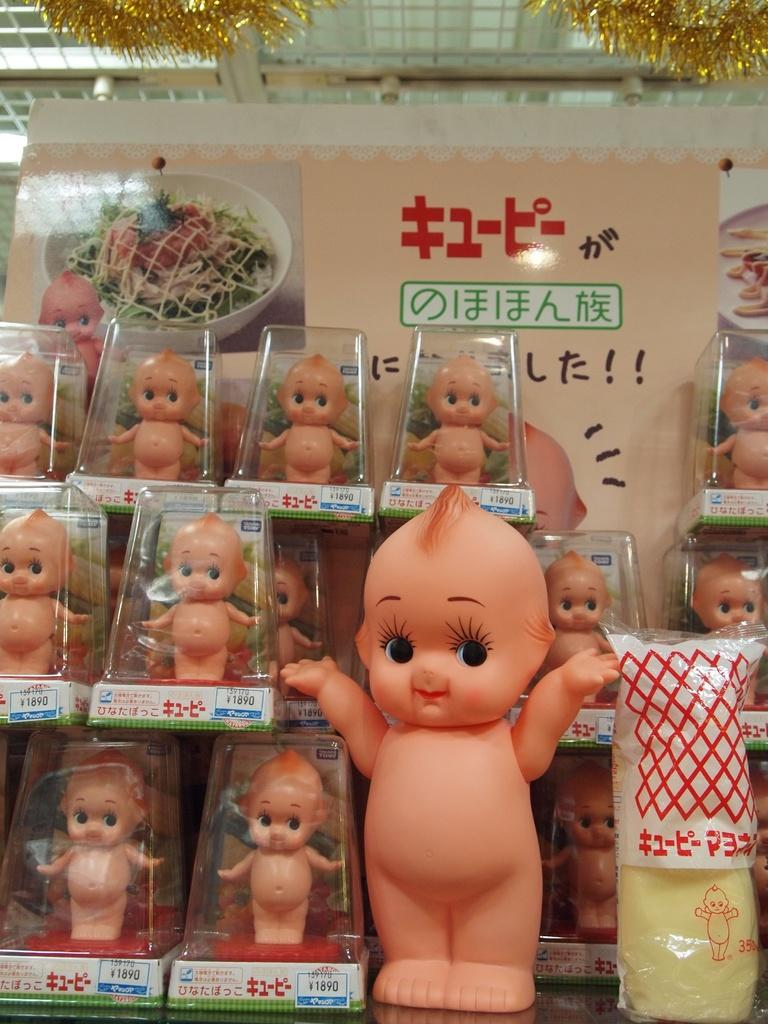What is located in the center of the image? There are plastic packets in the center of the image. What is inside the plastic packets? The plastic packets contain baby toys. What can be seen in the background of the image? There is a wall, a banner, and decorative items in the background of the image. How many sheep can be seen in the image? There are no sheep present in the image. What type of adjustment is being made to the baby toys in the image? There is no adjustment being made to the baby toys in the image; they are simply contained within the plastic packets. 